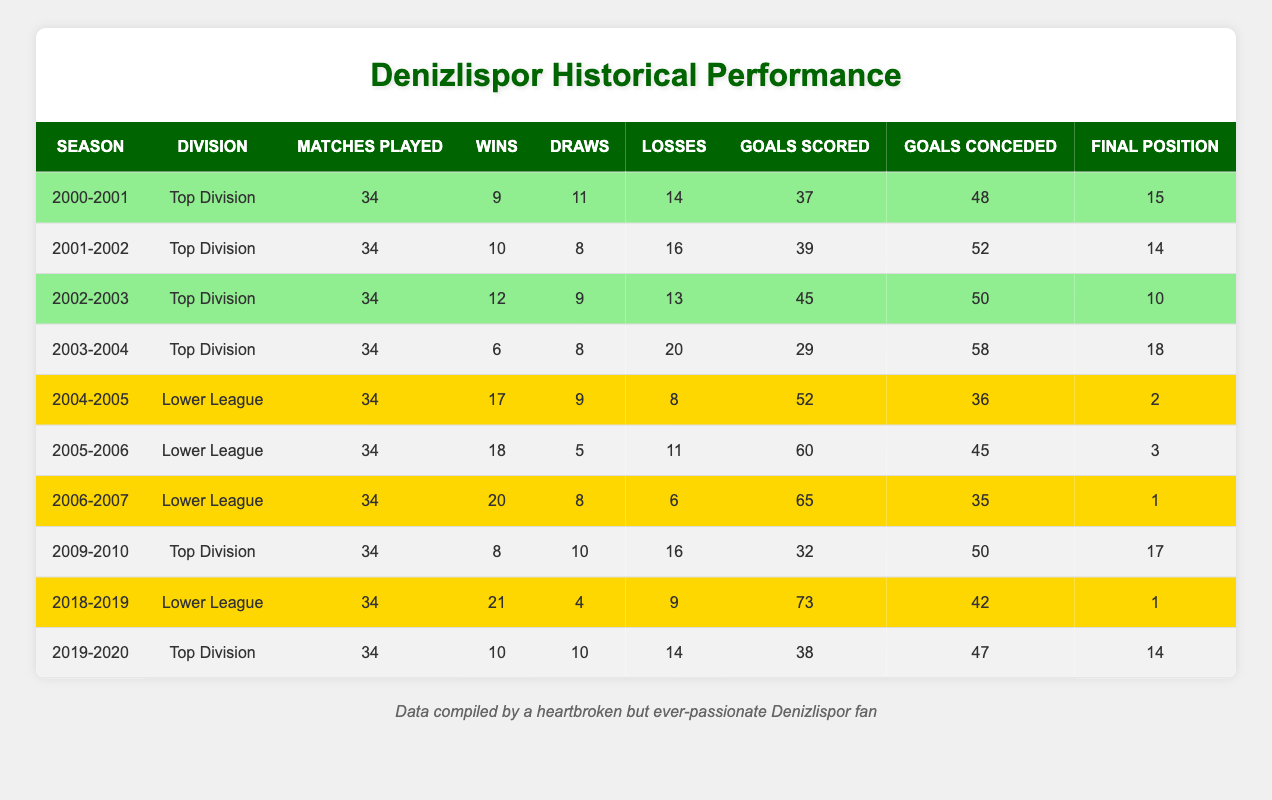What was Denizlispor's final position in the 2004-2005 season? The table indicates that in the 2004-2005 season, Denizlispor finished in 2nd place in the lower league. This information is found in the row corresponding to that season.
Answer: 2 How many wins did Denizlispor achieve in the 2005-2006 season? According to the table, in the 2005-2006 season, Denizlispor had a total of 18 wins. This is directly stated in the relevant row of the table.
Answer: 18 Which division did Denizlispor perform best in based on final positions? By comparing final positions across all seasons, it can be seen that the best position achieved was 1st place in the lower leagues during both the 2006-2007 and 2018-2019 seasons. This indicates superior performance in the lower leagues compared to the top division.
Answer: Lower League What is the average number of goals scored by Denizlispor in the top division across the years they played there? To find the average, first sum all goals scored in the top division: (37 + 39 + 45 + 29 + 32 + 38) = 220. There are 6 seasons in the top division, so the average is 220/6 = approximately 36.67.
Answer: 36.67 Did Denizlispor ever finish in the bottom half of the standings in the top division? Yes, looking at the table, Denizlispor finished in the bottom half (positions 9-18) during the seasons 2000-2001, 2003-2004, 2009-2010, and 2019-2020. This confirms that they had several instances of poor performance in the top division.
Answer: Yes What was the total number of matches played by Denizlispor in the lower leagues? The total number of matches in the lower league seasons can be calculated by adding the matches played across those seasons: 34 (2004-2005) + 34 (2005-2006) + 34 (2006-2007) + 34 (2018-2019) = 136. Thus, Denizlispor played a total of 136 matches in the lower leagues.
Answer: 136 In which season did Denizlispor score the most goals in the lower league? The highest number of goals scored in the lower league came during the 2018-2019 season when Denizlispor scored 73 goals, which is the maximum in the lower league rows.
Answer: 2018-2019 How many draws did Denizlispor have overall in the top division? To calculate overall draws in the top division, add the draws from each season: 11 (2000-2001) + 8 (2001-2002) + 9 (2002-2003) + 8 (2003-2004) + 10 (2009-2010) + 10 (2019-2020) = 56. Therefore, the total draws in the top division is 56.
Answer: 56 Was Denizlispor's performance in the lower league consistently superior to that in the top division? Evaluating the final positions and wins across season data shows that Denizlispor won more matches and achieved better final positions in the lower leagues compared to the top division, suggesting a trend of consistent better performance in lower league seasons.
Answer: Yes 